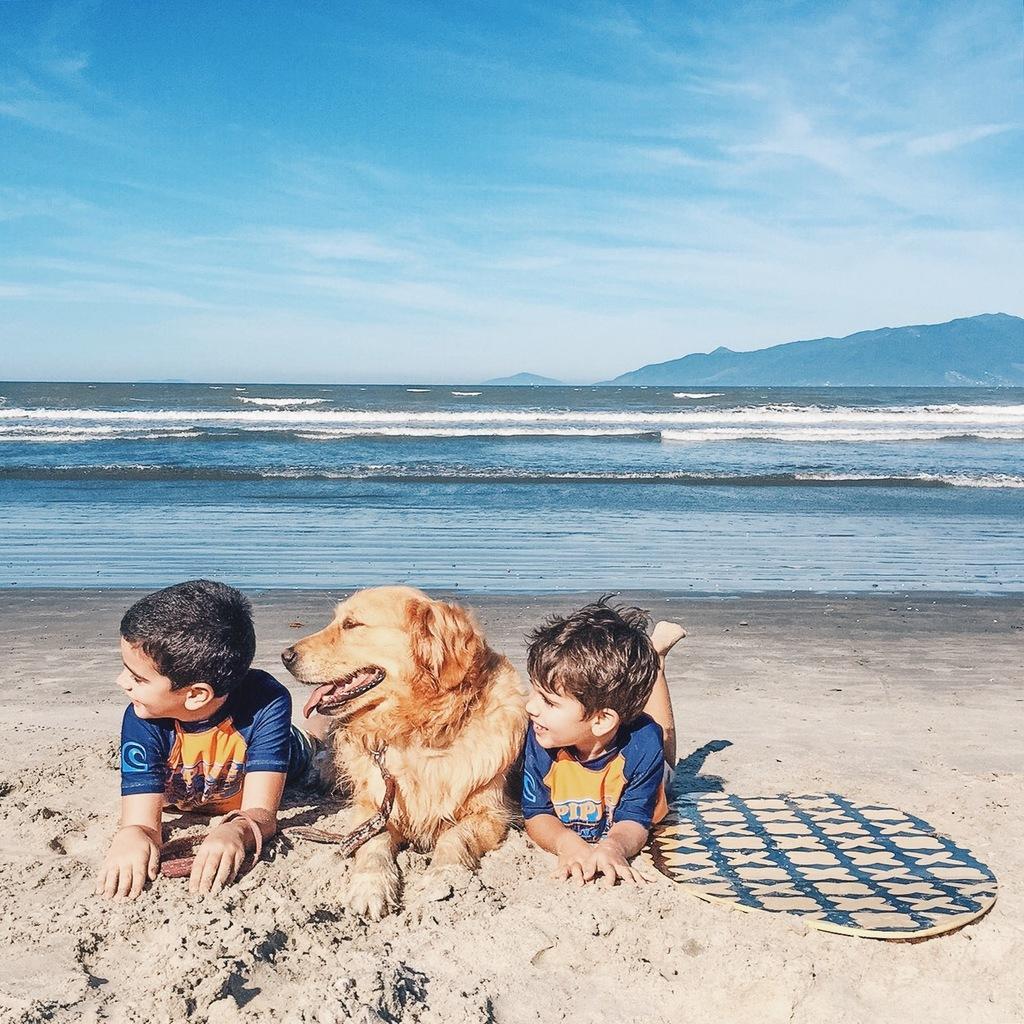Could you give a brief overview of what you see in this image? In the picture we can see two boys and a dog, two boys are wearing a blue T-shirts and laying on the sand and we can also see a mat beside them, background we can see a water, ocean, hills and a sky. 